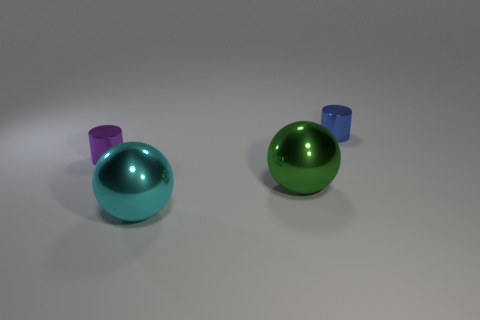Are there fewer big shiny spheres that are on the left side of the big green thing than red cylinders?
Keep it short and to the point. No. Is there a object that has the same size as the green shiny sphere?
Your response must be concise. Yes. What is the color of the small cylinder that is the same material as the tiny purple object?
Provide a short and direct response. Blue. How many green shiny balls are to the right of the green object that is in front of the tiny blue metal object?
Provide a short and direct response. 0. Is the shape of the small object left of the small blue cylinder the same as  the tiny blue object?
Make the answer very short. Yes. Are there fewer metal objects than cyan shiny spheres?
Offer a very short reply. No. Is the number of purple metallic cylinders greater than the number of blue rubber objects?
Offer a very short reply. Yes. What is the size of the other thing that is the same shape as the large green object?
Ensure brevity in your answer.  Large. What number of things are green objects or cyan things?
Offer a terse response. 2. There is a cylinder left of the small blue object; does it have the same size as the ball that is to the right of the big cyan shiny sphere?
Make the answer very short. No. 